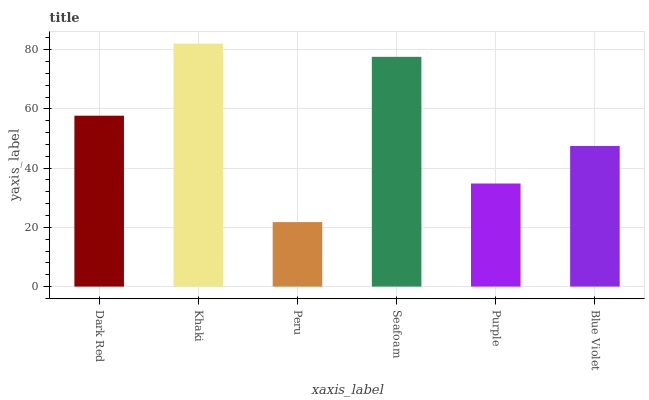Is Peru the minimum?
Answer yes or no. Yes. Is Khaki the maximum?
Answer yes or no. Yes. Is Khaki the minimum?
Answer yes or no. No. Is Peru the maximum?
Answer yes or no. No. Is Khaki greater than Peru?
Answer yes or no. Yes. Is Peru less than Khaki?
Answer yes or no. Yes. Is Peru greater than Khaki?
Answer yes or no. No. Is Khaki less than Peru?
Answer yes or no. No. Is Dark Red the high median?
Answer yes or no. Yes. Is Blue Violet the low median?
Answer yes or no. Yes. Is Blue Violet the high median?
Answer yes or no. No. Is Seafoam the low median?
Answer yes or no. No. 